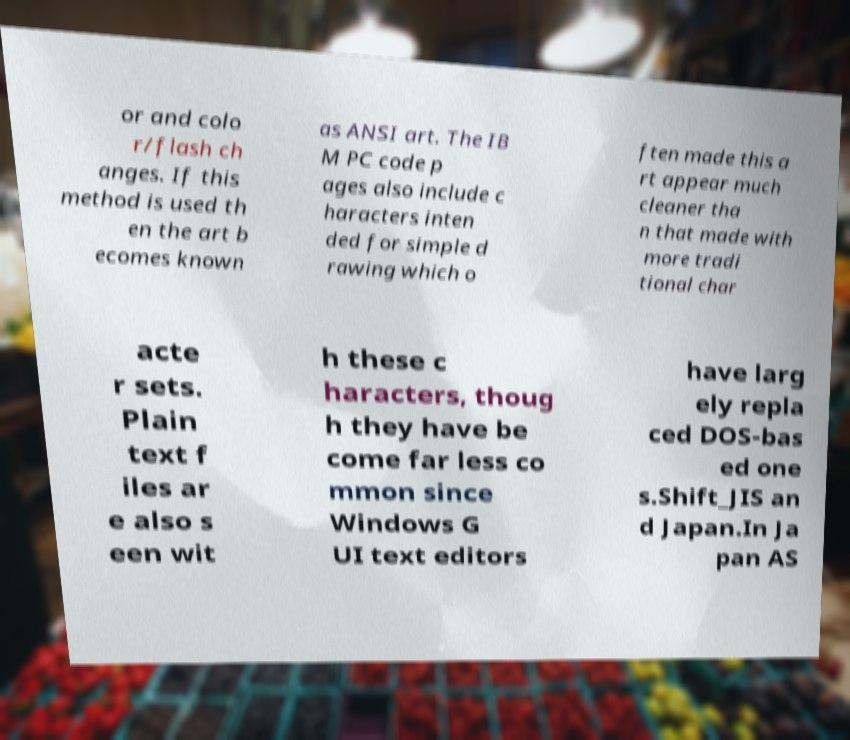Could you assist in decoding the text presented in this image and type it out clearly? or and colo r/flash ch anges. If this method is used th en the art b ecomes known as ANSI art. The IB M PC code p ages also include c haracters inten ded for simple d rawing which o ften made this a rt appear much cleaner tha n that made with more tradi tional char acte r sets. Plain text f iles ar e also s een wit h these c haracters, thoug h they have be come far less co mmon since Windows G UI text editors have larg ely repla ced DOS-bas ed one s.Shift_JIS an d Japan.In Ja pan AS 